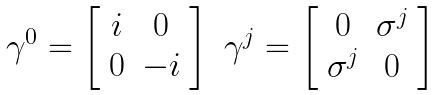<formula> <loc_0><loc_0><loc_500><loc_500>\begin{array} { c c } \gamma ^ { 0 } = \left [ \begin{array} { c c } i & 0 \\ 0 & - i \end{array} \right ] & \gamma ^ { j } = \left [ \begin{array} { c c } 0 & \sigma ^ { j } \\ \sigma ^ { j } & 0 \end{array} \right ] \end{array}</formula> 